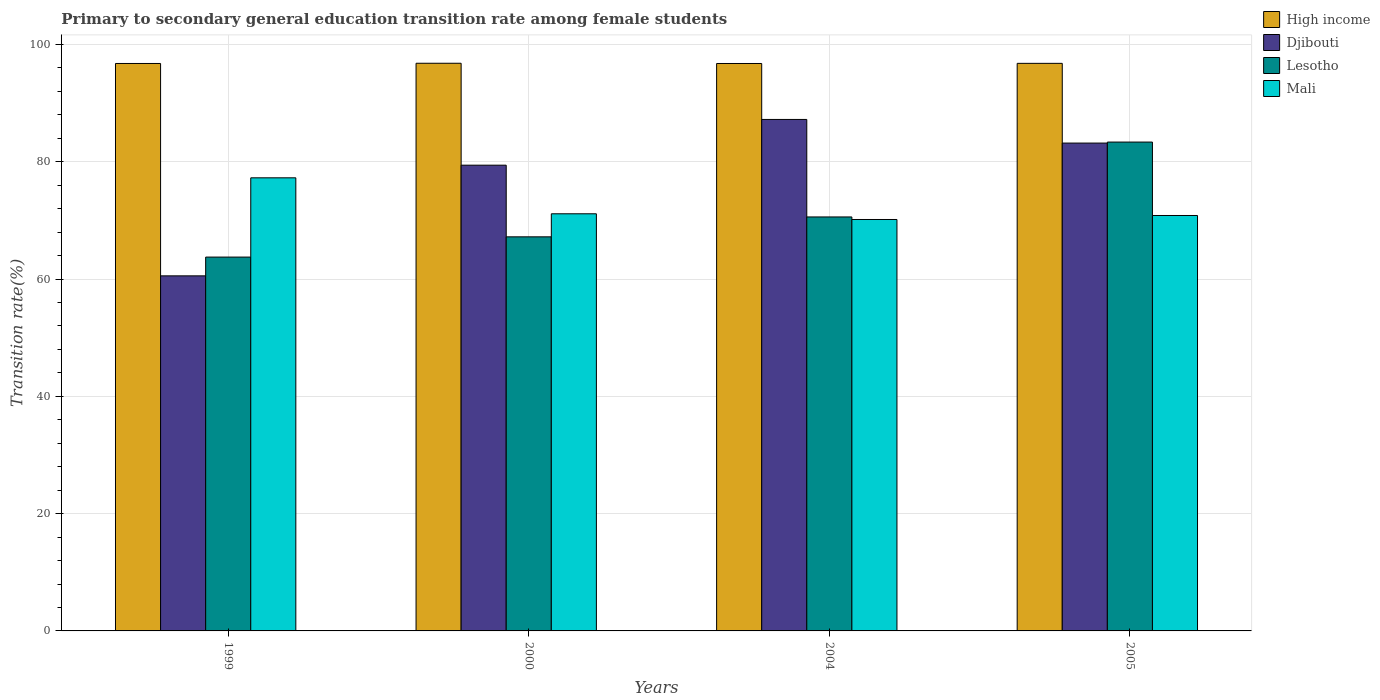How many different coloured bars are there?
Your answer should be compact. 4. How many groups of bars are there?
Offer a terse response. 4. Are the number of bars on each tick of the X-axis equal?
Your answer should be very brief. Yes. How many bars are there on the 4th tick from the right?
Offer a very short reply. 4. In how many cases, is the number of bars for a given year not equal to the number of legend labels?
Your answer should be very brief. 0. What is the transition rate in High income in 2005?
Ensure brevity in your answer.  96.78. Across all years, what is the maximum transition rate in Djibouti?
Make the answer very short. 87.22. Across all years, what is the minimum transition rate in High income?
Give a very brief answer. 96.76. In which year was the transition rate in Mali maximum?
Your response must be concise. 1999. What is the total transition rate in Lesotho in the graph?
Offer a very short reply. 284.89. What is the difference between the transition rate in Mali in 2004 and that in 2005?
Your response must be concise. -0.68. What is the difference between the transition rate in Djibouti in 2000 and the transition rate in Lesotho in 2005?
Give a very brief answer. -3.94. What is the average transition rate in Djibouti per year?
Provide a short and direct response. 77.59. In the year 2004, what is the difference between the transition rate in High income and transition rate in Mali?
Your answer should be very brief. 26.6. In how many years, is the transition rate in High income greater than 72 %?
Offer a terse response. 4. What is the ratio of the transition rate in Lesotho in 1999 to that in 2000?
Your answer should be very brief. 0.95. Is the transition rate in Lesotho in 2000 less than that in 2004?
Your answer should be very brief. Yes. Is the difference between the transition rate in High income in 2000 and 2004 greater than the difference between the transition rate in Mali in 2000 and 2004?
Keep it short and to the point. No. What is the difference between the highest and the second highest transition rate in High income?
Provide a short and direct response. 0.02. What is the difference between the highest and the lowest transition rate in High income?
Your answer should be very brief. 0.04. What does the 1st bar from the left in 1999 represents?
Give a very brief answer. High income. What does the 3rd bar from the right in 2004 represents?
Ensure brevity in your answer.  Djibouti. Are all the bars in the graph horizontal?
Give a very brief answer. No. How many years are there in the graph?
Provide a succinct answer. 4. Does the graph contain any zero values?
Your answer should be compact. No. Where does the legend appear in the graph?
Your response must be concise. Top right. How many legend labels are there?
Your response must be concise. 4. How are the legend labels stacked?
Your answer should be compact. Vertical. What is the title of the graph?
Give a very brief answer. Primary to secondary general education transition rate among female students. Does "Latin America(developing only)" appear as one of the legend labels in the graph?
Offer a very short reply. No. What is the label or title of the Y-axis?
Your answer should be compact. Transition rate(%). What is the Transition rate(%) of High income in 1999?
Provide a short and direct response. 96.76. What is the Transition rate(%) of Djibouti in 1999?
Provide a succinct answer. 60.55. What is the Transition rate(%) of Lesotho in 1999?
Provide a short and direct response. 63.75. What is the Transition rate(%) of Mali in 1999?
Your response must be concise. 77.26. What is the Transition rate(%) in High income in 2000?
Offer a terse response. 96.8. What is the Transition rate(%) in Djibouti in 2000?
Keep it short and to the point. 79.42. What is the Transition rate(%) of Lesotho in 2000?
Keep it short and to the point. 67.2. What is the Transition rate(%) in Mali in 2000?
Keep it short and to the point. 71.13. What is the Transition rate(%) of High income in 2004?
Give a very brief answer. 96.76. What is the Transition rate(%) of Djibouti in 2004?
Provide a short and direct response. 87.22. What is the Transition rate(%) of Lesotho in 2004?
Provide a short and direct response. 70.59. What is the Transition rate(%) in Mali in 2004?
Provide a succinct answer. 70.16. What is the Transition rate(%) of High income in 2005?
Your answer should be compact. 96.78. What is the Transition rate(%) of Djibouti in 2005?
Your answer should be very brief. 83.19. What is the Transition rate(%) of Lesotho in 2005?
Keep it short and to the point. 83.36. What is the Transition rate(%) of Mali in 2005?
Ensure brevity in your answer.  70.84. Across all years, what is the maximum Transition rate(%) of High income?
Keep it short and to the point. 96.8. Across all years, what is the maximum Transition rate(%) of Djibouti?
Offer a terse response. 87.22. Across all years, what is the maximum Transition rate(%) in Lesotho?
Your answer should be very brief. 83.36. Across all years, what is the maximum Transition rate(%) in Mali?
Offer a terse response. 77.26. Across all years, what is the minimum Transition rate(%) of High income?
Your answer should be compact. 96.76. Across all years, what is the minimum Transition rate(%) of Djibouti?
Provide a succinct answer. 60.55. Across all years, what is the minimum Transition rate(%) in Lesotho?
Your response must be concise. 63.75. Across all years, what is the minimum Transition rate(%) of Mali?
Offer a terse response. 70.16. What is the total Transition rate(%) of High income in the graph?
Give a very brief answer. 387.1. What is the total Transition rate(%) of Djibouti in the graph?
Make the answer very short. 310.37. What is the total Transition rate(%) of Lesotho in the graph?
Your response must be concise. 284.89. What is the total Transition rate(%) of Mali in the graph?
Ensure brevity in your answer.  289.39. What is the difference between the Transition rate(%) of High income in 1999 and that in 2000?
Your answer should be very brief. -0.04. What is the difference between the Transition rate(%) in Djibouti in 1999 and that in 2000?
Keep it short and to the point. -18.87. What is the difference between the Transition rate(%) of Lesotho in 1999 and that in 2000?
Offer a very short reply. -3.45. What is the difference between the Transition rate(%) of Mali in 1999 and that in 2000?
Provide a succinct answer. 6.13. What is the difference between the Transition rate(%) in High income in 1999 and that in 2004?
Keep it short and to the point. 0. What is the difference between the Transition rate(%) in Djibouti in 1999 and that in 2004?
Your answer should be compact. -26.67. What is the difference between the Transition rate(%) of Lesotho in 1999 and that in 2004?
Your response must be concise. -6.84. What is the difference between the Transition rate(%) in Mali in 1999 and that in 2004?
Your answer should be compact. 7.11. What is the difference between the Transition rate(%) in High income in 1999 and that in 2005?
Offer a very short reply. -0.02. What is the difference between the Transition rate(%) of Djibouti in 1999 and that in 2005?
Offer a terse response. -22.64. What is the difference between the Transition rate(%) of Lesotho in 1999 and that in 2005?
Make the answer very short. -19.61. What is the difference between the Transition rate(%) in Mali in 1999 and that in 2005?
Your answer should be very brief. 6.42. What is the difference between the Transition rate(%) of High income in 2000 and that in 2004?
Your answer should be compact. 0.04. What is the difference between the Transition rate(%) of Djibouti in 2000 and that in 2004?
Make the answer very short. -7.8. What is the difference between the Transition rate(%) in Lesotho in 2000 and that in 2004?
Your answer should be very brief. -3.39. What is the difference between the Transition rate(%) in Mali in 2000 and that in 2004?
Give a very brief answer. 0.97. What is the difference between the Transition rate(%) of High income in 2000 and that in 2005?
Provide a short and direct response. 0.02. What is the difference between the Transition rate(%) of Djibouti in 2000 and that in 2005?
Your answer should be very brief. -3.77. What is the difference between the Transition rate(%) in Lesotho in 2000 and that in 2005?
Offer a very short reply. -16.16. What is the difference between the Transition rate(%) in Mali in 2000 and that in 2005?
Your answer should be very brief. 0.29. What is the difference between the Transition rate(%) in High income in 2004 and that in 2005?
Provide a short and direct response. -0.02. What is the difference between the Transition rate(%) of Djibouti in 2004 and that in 2005?
Your answer should be very brief. 4.03. What is the difference between the Transition rate(%) in Lesotho in 2004 and that in 2005?
Give a very brief answer. -12.77. What is the difference between the Transition rate(%) in Mali in 2004 and that in 2005?
Give a very brief answer. -0.68. What is the difference between the Transition rate(%) of High income in 1999 and the Transition rate(%) of Djibouti in 2000?
Offer a terse response. 17.34. What is the difference between the Transition rate(%) in High income in 1999 and the Transition rate(%) in Lesotho in 2000?
Your response must be concise. 29.56. What is the difference between the Transition rate(%) of High income in 1999 and the Transition rate(%) of Mali in 2000?
Your answer should be compact. 25.63. What is the difference between the Transition rate(%) in Djibouti in 1999 and the Transition rate(%) in Lesotho in 2000?
Keep it short and to the point. -6.65. What is the difference between the Transition rate(%) of Djibouti in 1999 and the Transition rate(%) of Mali in 2000?
Offer a terse response. -10.58. What is the difference between the Transition rate(%) in Lesotho in 1999 and the Transition rate(%) in Mali in 2000?
Keep it short and to the point. -7.38. What is the difference between the Transition rate(%) of High income in 1999 and the Transition rate(%) of Djibouti in 2004?
Keep it short and to the point. 9.54. What is the difference between the Transition rate(%) in High income in 1999 and the Transition rate(%) in Lesotho in 2004?
Offer a terse response. 26.17. What is the difference between the Transition rate(%) in High income in 1999 and the Transition rate(%) in Mali in 2004?
Offer a very short reply. 26.6. What is the difference between the Transition rate(%) in Djibouti in 1999 and the Transition rate(%) in Lesotho in 2004?
Provide a succinct answer. -10.04. What is the difference between the Transition rate(%) in Djibouti in 1999 and the Transition rate(%) in Mali in 2004?
Ensure brevity in your answer.  -9.61. What is the difference between the Transition rate(%) in Lesotho in 1999 and the Transition rate(%) in Mali in 2004?
Make the answer very short. -6.41. What is the difference between the Transition rate(%) of High income in 1999 and the Transition rate(%) of Djibouti in 2005?
Offer a terse response. 13.57. What is the difference between the Transition rate(%) of High income in 1999 and the Transition rate(%) of Lesotho in 2005?
Your answer should be compact. 13.4. What is the difference between the Transition rate(%) of High income in 1999 and the Transition rate(%) of Mali in 2005?
Provide a short and direct response. 25.92. What is the difference between the Transition rate(%) in Djibouti in 1999 and the Transition rate(%) in Lesotho in 2005?
Your response must be concise. -22.81. What is the difference between the Transition rate(%) of Djibouti in 1999 and the Transition rate(%) of Mali in 2005?
Provide a short and direct response. -10.29. What is the difference between the Transition rate(%) of Lesotho in 1999 and the Transition rate(%) of Mali in 2005?
Provide a short and direct response. -7.09. What is the difference between the Transition rate(%) in High income in 2000 and the Transition rate(%) in Djibouti in 2004?
Your answer should be very brief. 9.58. What is the difference between the Transition rate(%) in High income in 2000 and the Transition rate(%) in Lesotho in 2004?
Ensure brevity in your answer.  26.21. What is the difference between the Transition rate(%) in High income in 2000 and the Transition rate(%) in Mali in 2004?
Make the answer very short. 26.64. What is the difference between the Transition rate(%) of Djibouti in 2000 and the Transition rate(%) of Lesotho in 2004?
Your answer should be compact. 8.83. What is the difference between the Transition rate(%) of Djibouti in 2000 and the Transition rate(%) of Mali in 2004?
Provide a succinct answer. 9.26. What is the difference between the Transition rate(%) of Lesotho in 2000 and the Transition rate(%) of Mali in 2004?
Make the answer very short. -2.96. What is the difference between the Transition rate(%) in High income in 2000 and the Transition rate(%) in Djibouti in 2005?
Offer a terse response. 13.61. What is the difference between the Transition rate(%) in High income in 2000 and the Transition rate(%) in Lesotho in 2005?
Your response must be concise. 13.44. What is the difference between the Transition rate(%) of High income in 2000 and the Transition rate(%) of Mali in 2005?
Offer a very short reply. 25.96. What is the difference between the Transition rate(%) in Djibouti in 2000 and the Transition rate(%) in Lesotho in 2005?
Make the answer very short. -3.94. What is the difference between the Transition rate(%) of Djibouti in 2000 and the Transition rate(%) of Mali in 2005?
Offer a terse response. 8.58. What is the difference between the Transition rate(%) in Lesotho in 2000 and the Transition rate(%) in Mali in 2005?
Your answer should be compact. -3.64. What is the difference between the Transition rate(%) of High income in 2004 and the Transition rate(%) of Djibouti in 2005?
Make the answer very short. 13.57. What is the difference between the Transition rate(%) in High income in 2004 and the Transition rate(%) in Lesotho in 2005?
Your answer should be very brief. 13.4. What is the difference between the Transition rate(%) in High income in 2004 and the Transition rate(%) in Mali in 2005?
Your answer should be very brief. 25.92. What is the difference between the Transition rate(%) of Djibouti in 2004 and the Transition rate(%) of Lesotho in 2005?
Offer a terse response. 3.86. What is the difference between the Transition rate(%) in Djibouti in 2004 and the Transition rate(%) in Mali in 2005?
Provide a succinct answer. 16.38. What is the difference between the Transition rate(%) of Lesotho in 2004 and the Transition rate(%) of Mali in 2005?
Your answer should be very brief. -0.25. What is the average Transition rate(%) of High income per year?
Keep it short and to the point. 96.77. What is the average Transition rate(%) in Djibouti per year?
Provide a succinct answer. 77.59. What is the average Transition rate(%) of Lesotho per year?
Ensure brevity in your answer.  71.22. What is the average Transition rate(%) in Mali per year?
Provide a succinct answer. 72.35. In the year 1999, what is the difference between the Transition rate(%) of High income and Transition rate(%) of Djibouti?
Give a very brief answer. 36.21. In the year 1999, what is the difference between the Transition rate(%) in High income and Transition rate(%) in Lesotho?
Offer a very short reply. 33.01. In the year 1999, what is the difference between the Transition rate(%) of High income and Transition rate(%) of Mali?
Your answer should be compact. 19.5. In the year 1999, what is the difference between the Transition rate(%) of Djibouti and Transition rate(%) of Lesotho?
Make the answer very short. -3.2. In the year 1999, what is the difference between the Transition rate(%) of Djibouti and Transition rate(%) of Mali?
Offer a very short reply. -16.72. In the year 1999, what is the difference between the Transition rate(%) of Lesotho and Transition rate(%) of Mali?
Provide a short and direct response. -13.52. In the year 2000, what is the difference between the Transition rate(%) of High income and Transition rate(%) of Djibouti?
Make the answer very short. 17.38. In the year 2000, what is the difference between the Transition rate(%) of High income and Transition rate(%) of Lesotho?
Your answer should be compact. 29.6. In the year 2000, what is the difference between the Transition rate(%) in High income and Transition rate(%) in Mali?
Offer a very short reply. 25.67. In the year 2000, what is the difference between the Transition rate(%) in Djibouti and Transition rate(%) in Lesotho?
Ensure brevity in your answer.  12.22. In the year 2000, what is the difference between the Transition rate(%) in Djibouti and Transition rate(%) in Mali?
Ensure brevity in your answer.  8.29. In the year 2000, what is the difference between the Transition rate(%) of Lesotho and Transition rate(%) of Mali?
Your answer should be very brief. -3.93. In the year 2004, what is the difference between the Transition rate(%) of High income and Transition rate(%) of Djibouti?
Offer a very short reply. 9.54. In the year 2004, what is the difference between the Transition rate(%) of High income and Transition rate(%) of Lesotho?
Ensure brevity in your answer.  26.17. In the year 2004, what is the difference between the Transition rate(%) in High income and Transition rate(%) in Mali?
Keep it short and to the point. 26.6. In the year 2004, what is the difference between the Transition rate(%) of Djibouti and Transition rate(%) of Lesotho?
Provide a succinct answer. 16.63. In the year 2004, what is the difference between the Transition rate(%) of Djibouti and Transition rate(%) of Mali?
Your answer should be very brief. 17.06. In the year 2004, what is the difference between the Transition rate(%) of Lesotho and Transition rate(%) of Mali?
Provide a short and direct response. 0.43. In the year 2005, what is the difference between the Transition rate(%) in High income and Transition rate(%) in Djibouti?
Offer a terse response. 13.59. In the year 2005, what is the difference between the Transition rate(%) in High income and Transition rate(%) in Lesotho?
Offer a terse response. 13.42. In the year 2005, what is the difference between the Transition rate(%) in High income and Transition rate(%) in Mali?
Your answer should be very brief. 25.94. In the year 2005, what is the difference between the Transition rate(%) of Djibouti and Transition rate(%) of Lesotho?
Make the answer very short. -0.17. In the year 2005, what is the difference between the Transition rate(%) in Djibouti and Transition rate(%) in Mali?
Keep it short and to the point. 12.35. In the year 2005, what is the difference between the Transition rate(%) in Lesotho and Transition rate(%) in Mali?
Give a very brief answer. 12.52. What is the ratio of the Transition rate(%) in Djibouti in 1999 to that in 2000?
Your response must be concise. 0.76. What is the ratio of the Transition rate(%) of Lesotho in 1999 to that in 2000?
Provide a short and direct response. 0.95. What is the ratio of the Transition rate(%) of Mali in 1999 to that in 2000?
Make the answer very short. 1.09. What is the ratio of the Transition rate(%) in Djibouti in 1999 to that in 2004?
Provide a succinct answer. 0.69. What is the ratio of the Transition rate(%) in Lesotho in 1999 to that in 2004?
Provide a short and direct response. 0.9. What is the ratio of the Transition rate(%) of Mali in 1999 to that in 2004?
Offer a terse response. 1.1. What is the ratio of the Transition rate(%) of High income in 1999 to that in 2005?
Ensure brevity in your answer.  1. What is the ratio of the Transition rate(%) in Djibouti in 1999 to that in 2005?
Your answer should be compact. 0.73. What is the ratio of the Transition rate(%) in Lesotho in 1999 to that in 2005?
Give a very brief answer. 0.76. What is the ratio of the Transition rate(%) in Mali in 1999 to that in 2005?
Provide a succinct answer. 1.09. What is the ratio of the Transition rate(%) of Djibouti in 2000 to that in 2004?
Your answer should be very brief. 0.91. What is the ratio of the Transition rate(%) in Lesotho in 2000 to that in 2004?
Make the answer very short. 0.95. What is the ratio of the Transition rate(%) in Mali in 2000 to that in 2004?
Give a very brief answer. 1.01. What is the ratio of the Transition rate(%) in High income in 2000 to that in 2005?
Offer a terse response. 1. What is the ratio of the Transition rate(%) of Djibouti in 2000 to that in 2005?
Keep it short and to the point. 0.95. What is the ratio of the Transition rate(%) of Lesotho in 2000 to that in 2005?
Make the answer very short. 0.81. What is the ratio of the Transition rate(%) in High income in 2004 to that in 2005?
Your answer should be compact. 1. What is the ratio of the Transition rate(%) in Djibouti in 2004 to that in 2005?
Provide a succinct answer. 1.05. What is the ratio of the Transition rate(%) in Lesotho in 2004 to that in 2005?
Your answer should be very brief. 0.85. What is the ratio of the Transition rate(%) of Mali in 2004 to that in 2005?
Ensure brevity in your answer.  0.99. What is the difference between the highest and the second highest Transition rate(%) of High income?
Ensure brevity in your answer.  0.02. What is the difference between the highest and the second highest Transition rate(%) of Djibouti?
Provide a succinct answer. 4.03. What is the difference between the highest and the second highest Transition rate(%) in Lesotho?
Offer a very short reply. 12.77. What is the difference between the highest and the second highest Transition rate(%) in Mali?
Your response must be concise. 6.13. What is the difference between the highest and the lowest Transition rate(%) of High income?
Your response must be concise. 0.04. What is the difference between the highest and the lowest Transition rate(%) of Djibouti?
Your answer should be compact. 26.67. What is the difference between the highest and the lowest Transition rate(%) of Lesotho?
Give a very brief answer. 19.61. What is the difference between the highest and the lowest Transition rate(%) in Mali?
Offer a terse response. 7.11. 